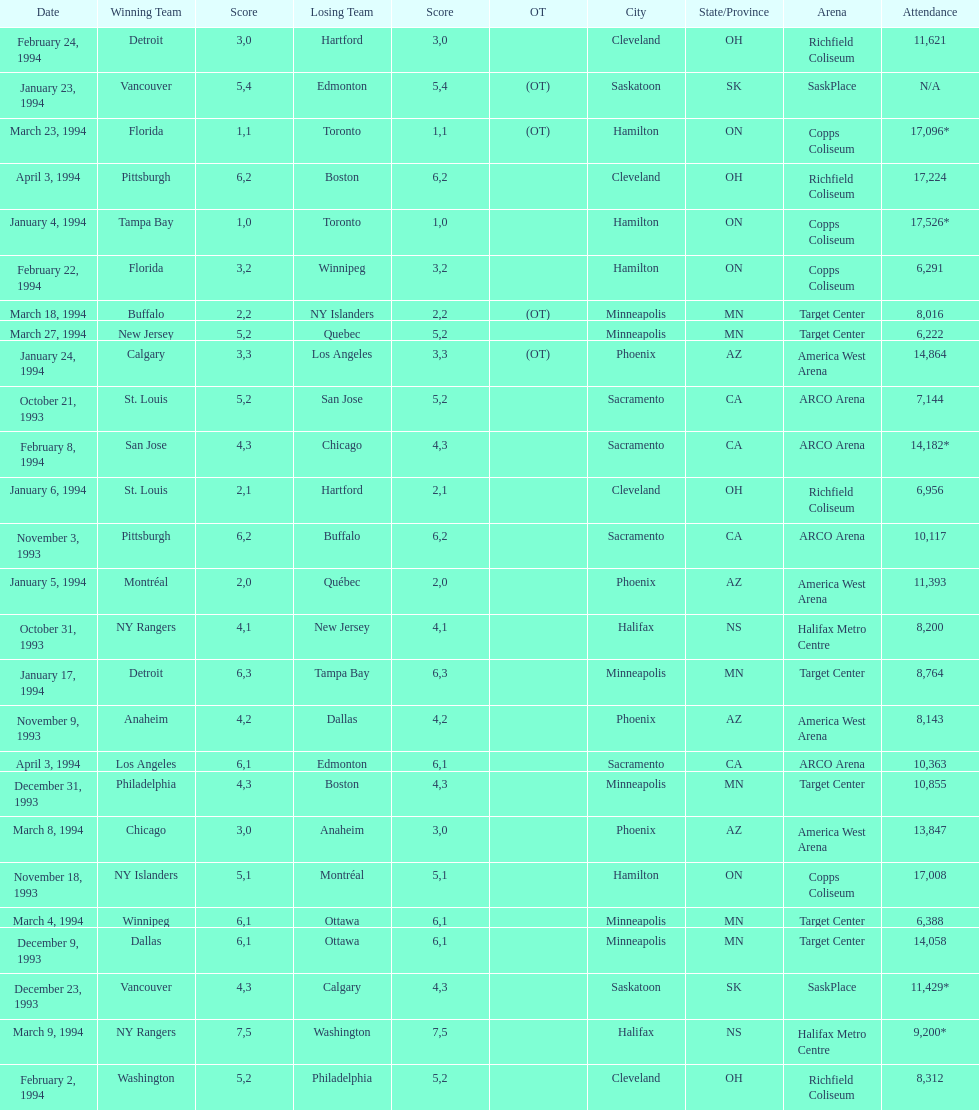When was the game with the most spectators held? January 4, 1994. 